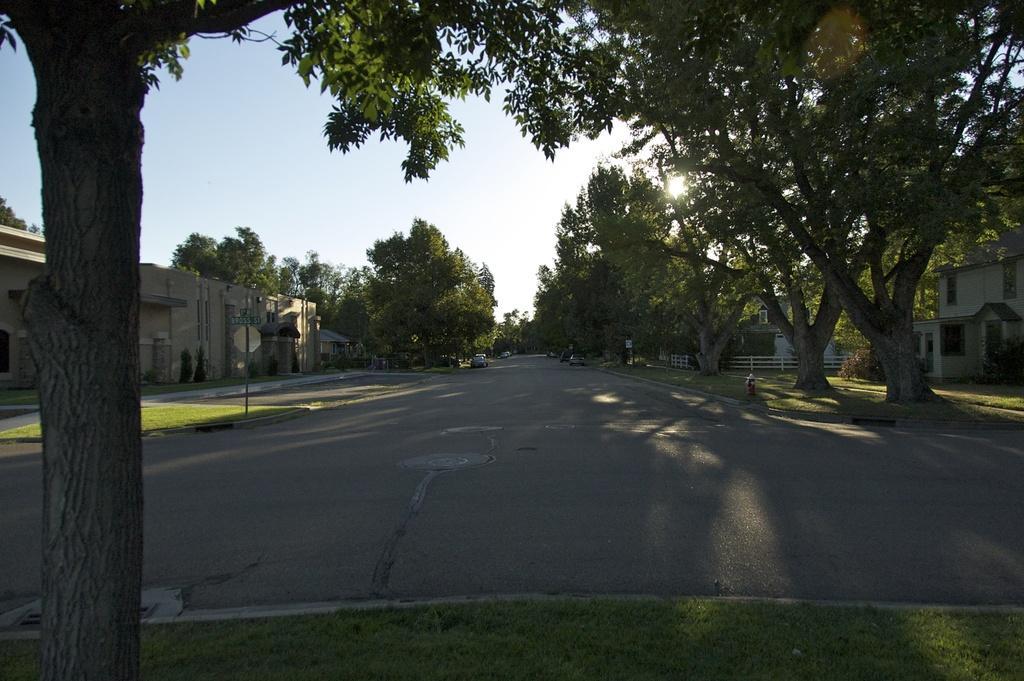Could you give a brief overview of what you see in this image? In this image on the left side we can see a tree and at the bottom grass on the ground. In the background vehicles on the road, boards on a pole, plants, trees, fence, hydrant, buildings, windows and sun in the sky. 